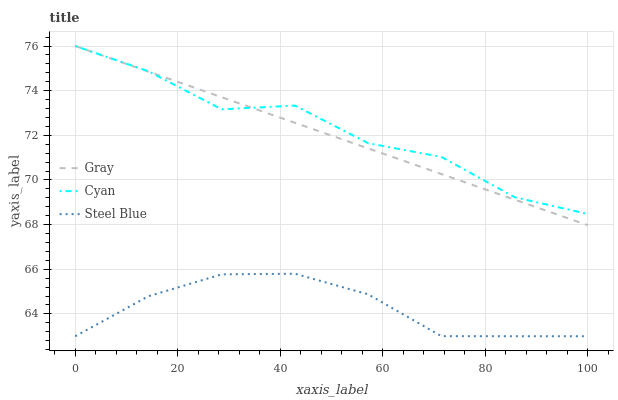Does Cyan have the minimum area under the curve?
Answer yes or no. No. Does Steel Blue have the maximum area under the curve?
Answer yes or no. No. Is Steel Blue the smoothest?
Answer yes or no. No. Is Steel Blue the roughest?
Answer yes or no. No. Does Cyan have the lowest value?
Answer yes or no. No. Does Steel Blue have the highest value?
Answer yes or no. No. Is Steel Blue less than Cyan?
Answer yes or no. Yes. Is Cyan greater than Steel Blue?
Answer yes or no. Yes. Does Steel Blue intersect Cyan?
Answer yes or no. No. 